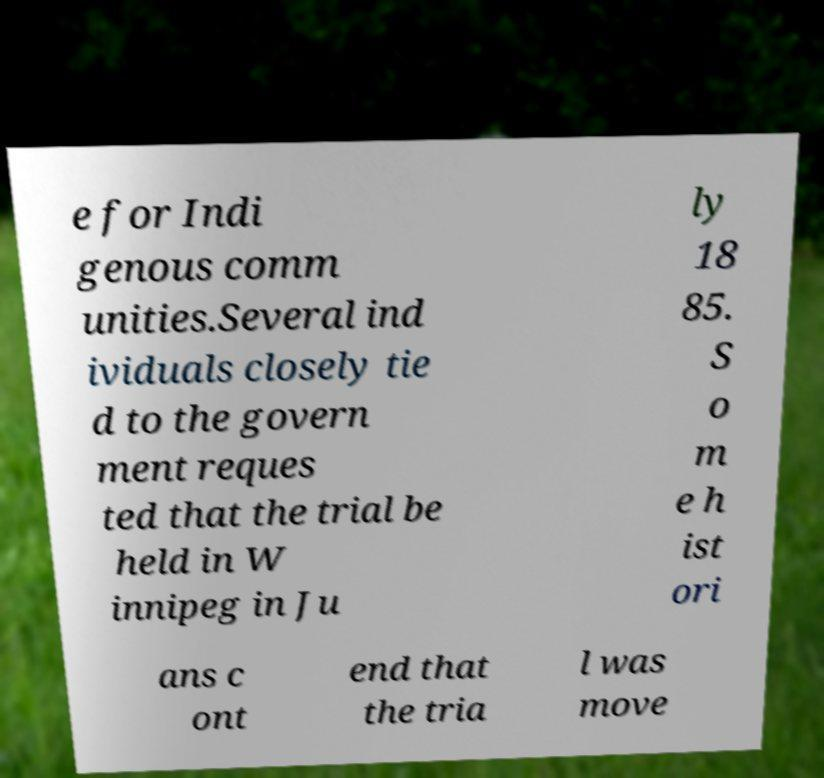Can you read and provide the text displayed in the image?This photo seems to have some interesting text. Can you extract and type it out for me? e for Indi genous comm unities.Several ind ividuals closely tie d to the govern ment reques ted that the trial be held in W innipeg in Ju ly 18 85. S o m e h ist ori ans c ont end that the tria l was move 